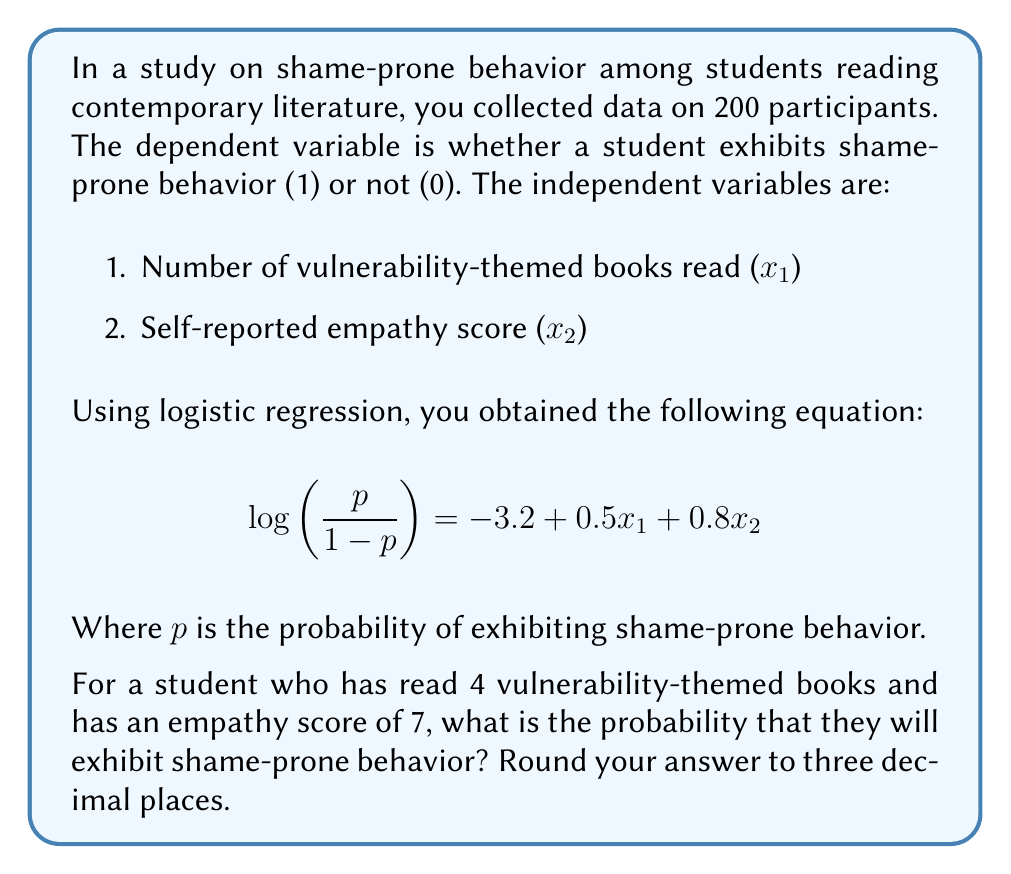Teach me how to tackle this problem. To solve this problem, we'll follow these steps:

1. Identify the logistic regression equation
2. Input the given values into the equation
3. Solve for $p$ (probability of shame-prone behavior)

Step 1: The logistic regression equation is given as:

$$ \log\left(\frac{p}{1-p}\right) = -3.2 + 0.5x_1 + 0.8x_2 $$

Step 2: We're given that $x_1 = 4$ (number of vulnerability-themed books read) and $x_2 = 7$ (empathy score). Let's substitute these values:

$$ \log\left(\frac{p}{1-p}\right) = -3.2 + 0.5(4) + 0.8(7) $$

$$ \log\left(\frac{p}{1-p}\right) = -3.2 + 2 + 5.6 $$

$$ \log\left(\frac{p}{1-p}\right) = 4.4 $$

Step 3: Now we need to solve for $p$. Let's call the left side of the equation $z$:

$$ z = 4.4 $$

$$ \frac{p}{1-p} = e^z = e^{4.4} $$

To solve for $p$, we use the formula:

$$ p = \frac{e^z}{1 + e^z} $$

Substituting our value:

$$ p = \frac{e^{4.4}}{1 + e^{4.4}} $$

Using a calculator:

$$ p = \frac{81.45}{82.45} \approx 0.9879 $$

Rounding to three decimal places, we get 0.988.
Answer: 0.988 